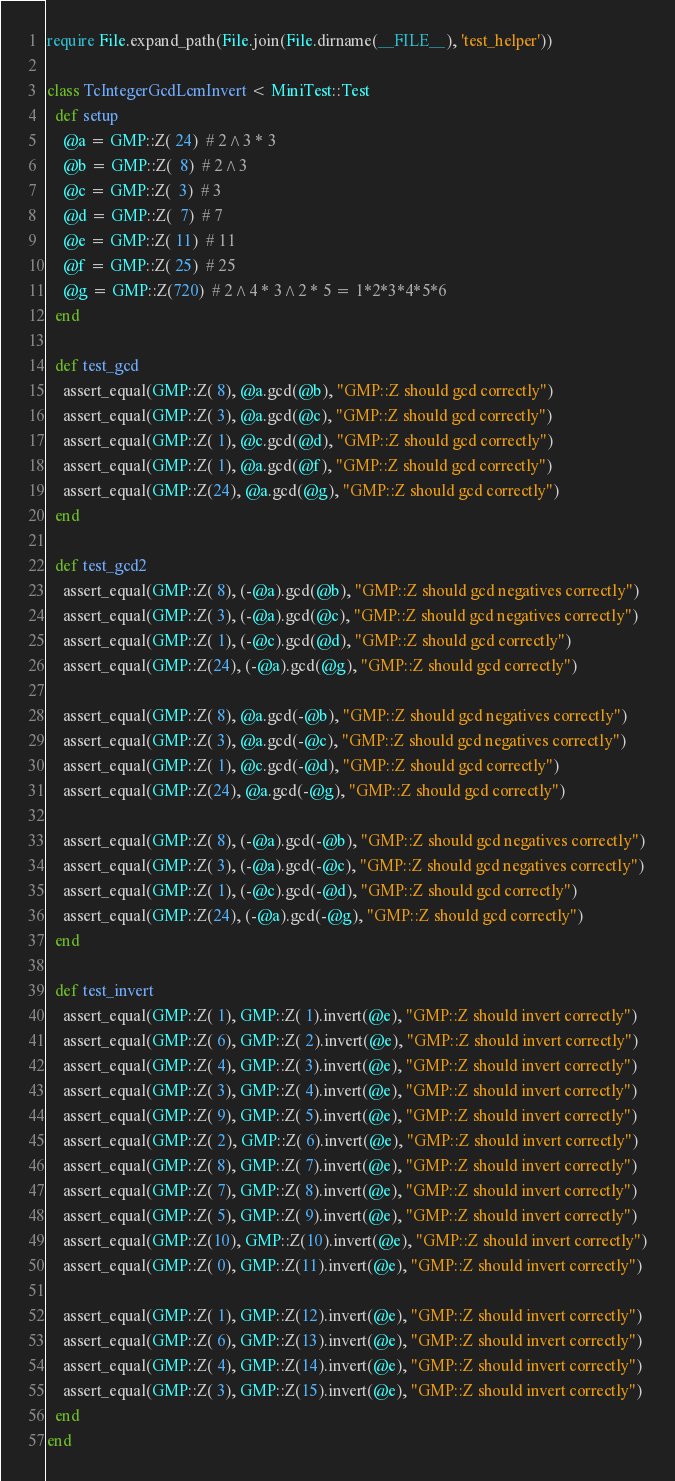<code> <loc_0><loc_0><loc_500><loc_500><_Ruby_>require File.expand_path(File.join(File.dirname(__FILE__), 'test_helper'))

class TcIntegerGcdLcmInvert < MiniTest::Test
  def setup
    @a = GMP::Z( 24)  # 2^3 * 3
    @b = GMP::Z(  8)  # 2^3
    @c = GMP::Z(  3)  # 3
    @d = GMP::Z(  7)  # 7
    @e = GMP::Z( 11)  # 11
    @f = GMP::Z( 25)  # 25
    @g = GMP::Z(720)  # 2^4 * 3^2 * 5 = 1*2*3*4*5*6
  end

  def test_gcd
    assert_equal(GMP::Z( 8), @a.gcd(@b), "GMP::Z should gcd correctly")
    assert_equal(GMP::Z( 3), @a.gcd(@c), "GMP::Z should gcd correctly")
    assert_equal(GMP::Z( 1), @c.gcd(@d), "GMP::Z should gcd correctly")
    assert_equal(GMP::Z( 1), @a.gcd(@f), "GMP::Z should gcd correctly")
    assert_equal(GMP::Z(24), @a.gcd(@g), "GMP::Z should gcd correctly")
  end
  
  def test_gcd2
    assert_equal(GMP::Z( 8), (-@a).gcd(@b), "GMP::Z should gcd negatives correctly")
    assert_equal(GMP::Z( 3), (-@a).gcd(@c), "GMP::Z should gcd negatives correctly")
    assert_equal(GMP::Z( 1), (-@c).gcd(@d), "GMP::Z should gcd correctly")
    assert_equal(GMP::Z(24), (-@a).gcd(@g), "GMP::Z should gcd correctly")
    
    assert_equal(GMP::Z( 8), @a.gcd(-@b), "GMP::Z should gcd negatives correctly")
    assert_equal(GMP::Z( 3), @a.gcd(-@c), "GMP::Z should gcd negatives correctly")
    assert_equal(GMP::Z( 1), @c.gcd(-@d), "GMP::Z should gcd correctly")
    assert_equal(GMP::Z(24), @a.gcd(-@g), "GMP::Z should gcd correctly")
    
    assert_equal(GMP::Z( 8), (-@a).gcd(-@b), "GMP::Z should gcd negatives correctly")
    assert_equal(GMP::Z( 3), (-@a).gcd(-@c), "GMP::Z should gcd negatives correctly")
    assert_equal(GMP::Z( 1), (-@c).gcd(-@d), "GMP::Z should gcd correctly")
    assert_equal(GMP::Z(24), (-@a).gcd(-@g), "GMP::Z should gcd correctly")
  end
  
  def test_invert
    assert_equal(GMP::Z( 1), GMP::Z( 1).invert(@e), "GMP::Z should invert correctly")
    assert_equal(GMP::Z( 6), GMP::Z( 2).invert(@e), "GMP::Z should invert correctly")
    assert_equal(GMP::Z( 4), GMP::Z( 3).invert(@e), "GMP::Z should invert correctly")
    assert_equal(GMP::Z( 3), GMP::Z( 4).invert(@e), "GMP::Z should invert correctly")
    assert_equal(GMP::Z( 9), GMP::Z( 5).invert(@e), "GMP::Z should invert correctly")
    assert_equal(GMP::Z( 2), GMP::Z( 6).invert(@e), "GMP::Z should invert correctly")
    assert_equal(GMP::Z( 8), GMP::Z( 7).invert(@e), "GMP::Z should invert correctly")
    assert_equal(GMP::Z( 7), GMP::Z( 8).invert(@e), "GMP::Z should invert correctly")
    assert_equal(GMP::Z( 5), GMP::Z( 9).invert(@e), "GMP::Z should invert correctly")
    assert_equal(GMP::Z(10), GMP::Z(10).invert(@e), "GMP::Z should invert correctly")
    assert_equal(GMP::Z( 0), GMP::Z(11).invert(@e), "GMP::Z should invert correctly")
    
    assert_equal(GMP::Z( 1), GMP::Z(12).invert(@e), "GMP::Z should invert correctly")
    assert_equal(GMP::Z( 6), GMP::Z(13).invert(@e), "GMP::Z should invert correctly")
    assert_equal(GMP::Z( 4), GMP::Z(14).invert(@e), "GMP::Z should invert correctly")
    assert_equal(GMP::Z( 3), GMP::Z(15).invert(@e), "GMP::Z should invert correctly")
  end
end
</code> 